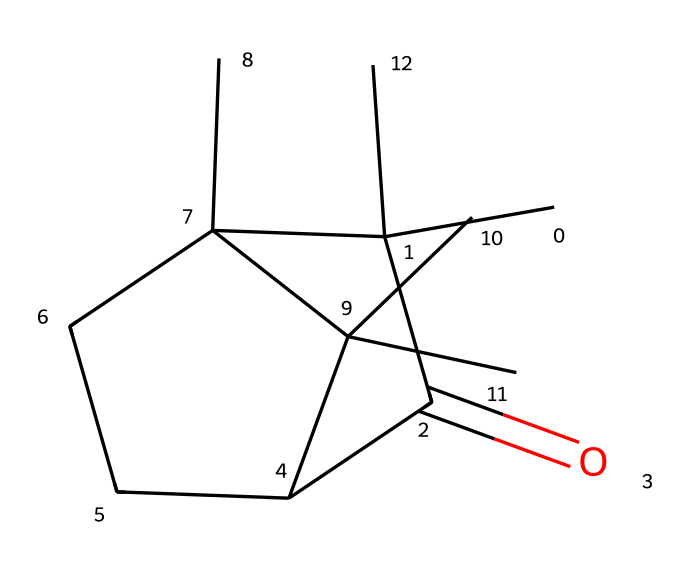What is the name of this chemical? The provided SMILES representation corresponds to the molecular structure of camphor, which is a compound known for its distinctive aroma and historical use in various applications, including mothballs.
Answer: camphor How many carbon atoms are present in the chemical? By analyzing the SMILES representation, we can count the carbon atoms represented by the 'C' symbols. There are 15 carbon atoms in total in the structure of camphor.
Answer: 15 What functional group is prominently featured in this structure? In the given SMILES, the presence of the carbonyl group (C=O) indicates that this molecule has a ketone functional group, which is important in defining its properties and reactivity.
Answer: ketone What type of scent is associated with camphor? Camphor is commonly known for its strong, aromatic scent that is often described as medicinal or penetrating, and this characteristic has made it popular in various applications, including fragrances and as a preservative.
Answer: medicinal What is the historical use of camphor in museums? Historically, camphor has been used in museums primarily for its role in textile preservation, particularly in mothballs, to protect fabrics from moth damage due to its insect-repellent properties.
Answer: textile preservation How does the molecular structure of camphor contribute to its volatility? The structure of camphor includes a polar carbonyl group, which enhances its evaporation rate, and the overall compact structure with cyclic components allows for easier transition into the vapor phase, contributing to its volatility.
Answer: volatility What role does camphor play in the formulation of fragrances? In fragrance formulations, camphor serves as a significant component that provides a cooling, refreshing scent, and its unique aromatic profile makes it valuable in the creation of various perfumes and scented products.
Answer: component 